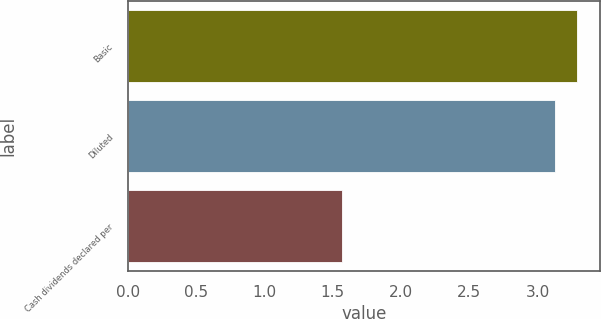<chart> <loc_0><loc_0><loc_500><loc_500><bar_chart><fcel>Basic<fcel>Diluted<fcel>Cash dividends declared per<nl><fcel>3.29<fcel>3.13<fcel>1.57<nl></chart> 